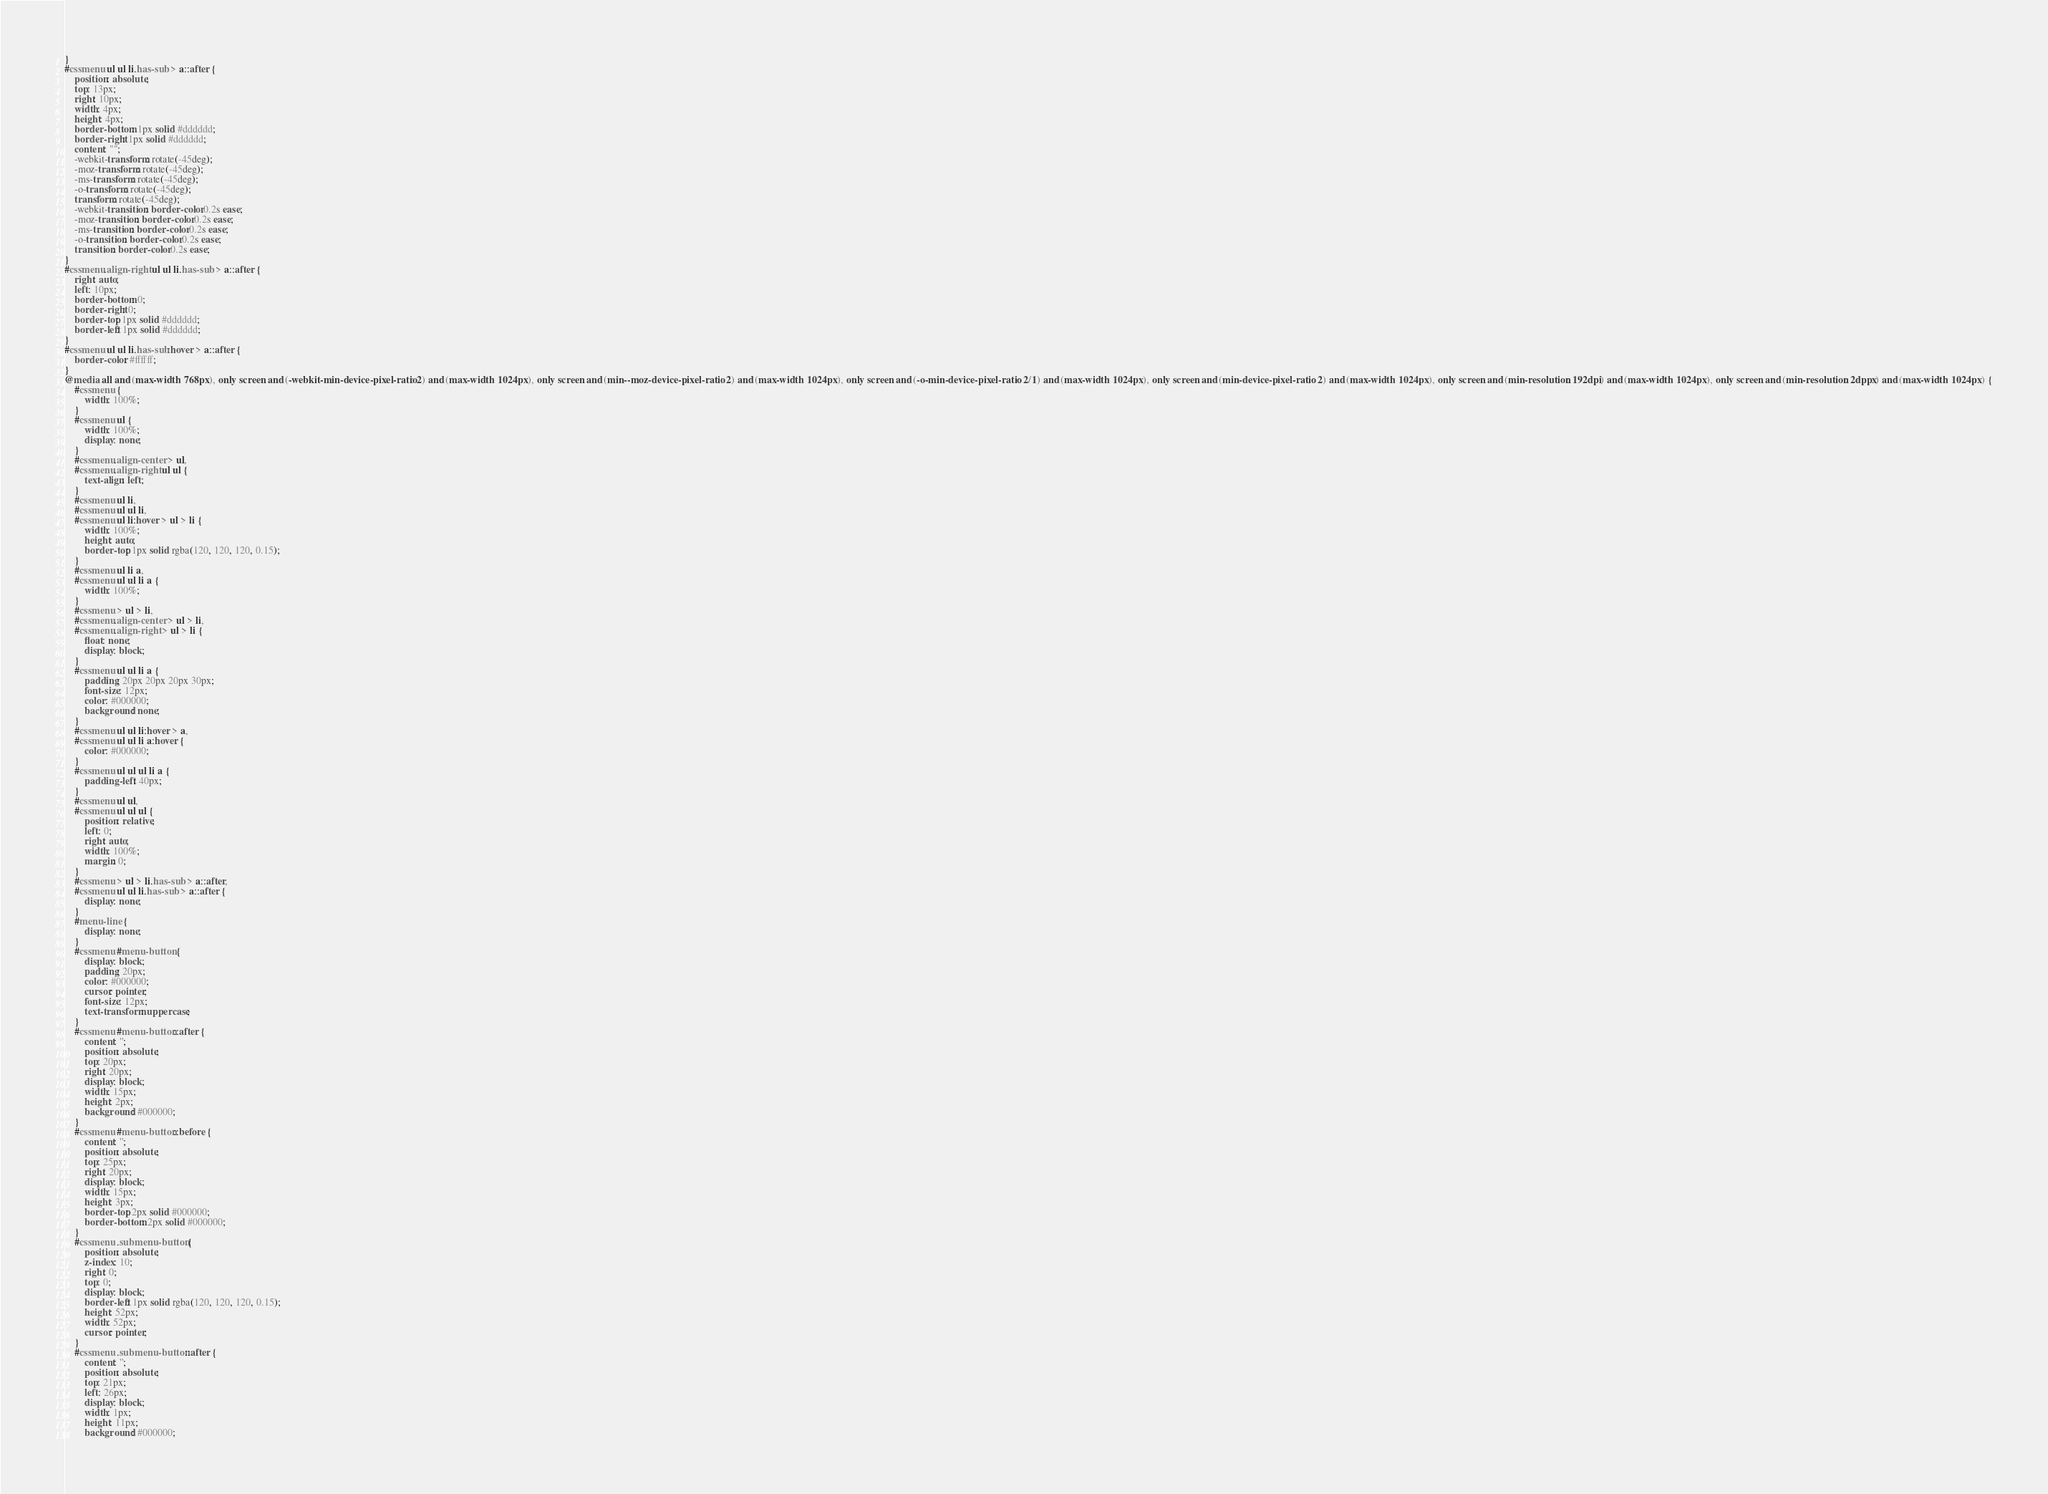<code> <loc_0><loc_0><loc_500><loc_500><_CSS_>}
#cssmenu ul ul li.has-sub > a::after {
	position: absolute;
	top: 13px;
	right: 10px;
	width: 4px;
	height: 4px;
	border-bottom: 1px solid #dddddd;
	border-right: 1px solid #dddddd;
	content: "";
	-webkit-transform: rotate(-45deg);
	-moz-transform: rotate(-45deg);
	-ms-transform: rotate(-45deg);
	-o-transform: rotate(-45deg);
	transform: rotate(-45deg);
	-webkit-transition: border-color 0.2s ease;
	-moz-transition: border-color 0.2s ease;
	-ms-transition: border-color 0.2s ease;
	-o-transition: border-color 0.2s ease;
	transition: border-color 0.2s ease;
}
#cssmenu.align-right ul ul li.has-sub > a::after {
	right: auto;
	left: 10px;
	border-bottom: 0;
	border-right: 0;
	border-top: 1px solid #dddddd;
	border-left: 1px solid #dddddd;
}
#cssmenu ul ul li.has-sub:hover > a::after {
	border-color: #ffffff;
}
@media all and (max-width: 768px), only screen and (-webkit-min-device-pixel-ratio: 2) and (max-width: 1024px), only screen and (min--moz-device-pixel-ratio: 2) and (max-width: 1024px), only screen and (-o-min-device-pixel-ratio: 2/1) and (max-width: 1024px), only screen and (min-device-pixel-ratio: 2) and (max-width: 1024px), only screen and (min-resolution: 192dpi) and (max-width: 1024px), only screen and (min-resolution: 2dppx) and (max-width: 1024px) {
	#cssmenu {
		width: 100%;
	}
	#cssmenu ul {
		width: 100%;
		display: none;
	}
	#cssmenu.align-center > ul,
	#cssmenu.align-right ul ul {
		text-align: left;
	}
	#cssmenu ul li,
	#cssmenu ul ul li,
	#cssmenu ul li:hover > ul > li {
		width: 100%;
		height: auto;
		border-top: 1px solid rgba(120, 120, 120, 0.15);
	}
	#cssmenu ul li a,
	#cssmenu ul ul li a {
		width: 100%;
	}
	#cssmenu > ul > li,
	#cssmenu.align-center > ul > li,
	#cssmenu.align-right > ul > li {
		float: none;
		display: block;
	}
	#cssmenu ul ul li a {
		padding: 20px 20px 20px 30px;
		font-size: 12px;
		color: #000000;
		background: none;
	}
	#cssmenu ul ul li:hover > a,
	#cssmenu ul ul li a:hover {
		color: #000000;
	}
	#cssmenu ul ul ul li a {
		padding-left: 40px;
	}
	#cssmenu ul ul,
	#cssmenu ul ul ul {
		position: relative;
		left: 0;
		right: auto;
		width: 100%;
		margin: 0;
	}
	#cssmenu > ul > li.has-sub > a::after,
	#cssmenu ul ul li.has-sub > a::after {
		display: none;
	}
	#menu-line {
		display: none;
	}
	#cssmenu #menu-button {
		display: block;
		padding: 20px;
		color: #000000;
		cursor: pointer;
		font-size: 12px;
		text-transform: uppercase;
	}
	#cssmenu #menu-button::after {
		content: '';
		position: absolute;
		top: 20px;
		right: 20px;
		display: block;
		width: 15px;
		height: 2px;
		background: #000000;
	}
	#cssmenu #menu-button::before {
		content: '';
		position: absolute;
		top: 25px;
		right: 20px;
		display: block;
		width: 15px;
		height: 3px;
		border-top: 2px solid #000000;
		border-bottom: 2px solid #000000;
	}
	#cssmenu .submenu-button {
		position: absolute;
		z-index: 10;
		right: 0;
		top: 0;
		display: block;
		border-left: 1px solid rgba(120, 120, 120, 0.15);
		height: 52px;
		width: 52px;
		cursor: pointer;
	}
	#cssmenu .submenu-button::after {
		content: '';
		position: absolute;
		top: 21px;
		left: 26px;
		display: block;
		width: 1px;
		height: 11px;
		background: #000000;</code> 